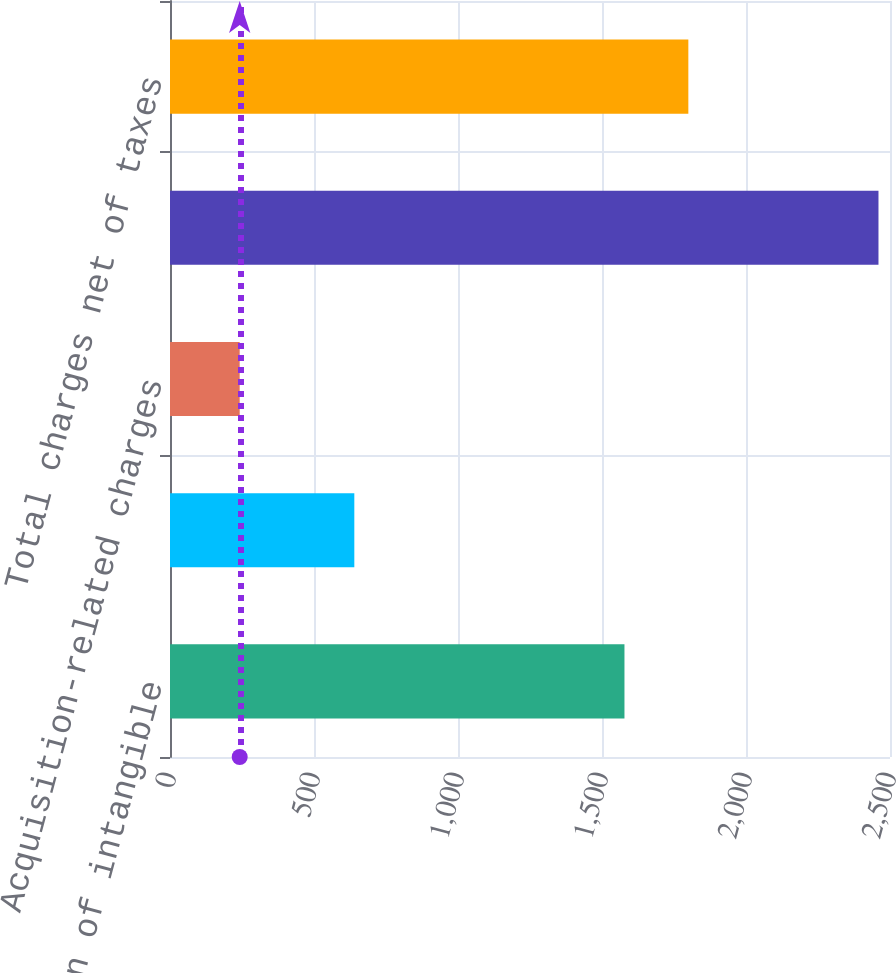Convert chart. <chart><loc_0><loc_0><loc_500><loc_500><bar_chart><fcel>Amortization of intangible<fcel>Restructuring charges<fcel>Acquisition-related charges<fcel>Total charges before taxes<fcel>Total charges net of taxes<nl><fcel>1578<fcel>640<fcel>242<fcel>2460<fcel>1799.8<nl></chart> 